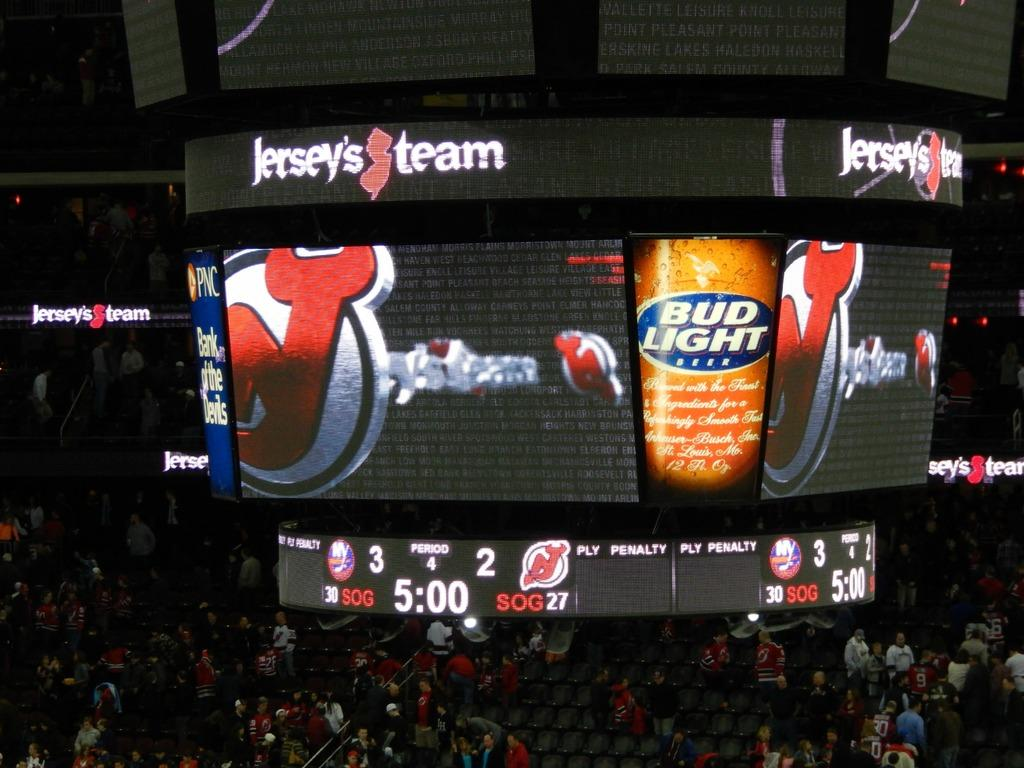<image>
Give a short and clear explanation of the subsequent image. Budlight is on the big screen of a game with a crowd of people there watching 